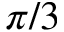<formula> <loc_0><loc_0><loc_500><loc_500>\pi / 3</formula> 